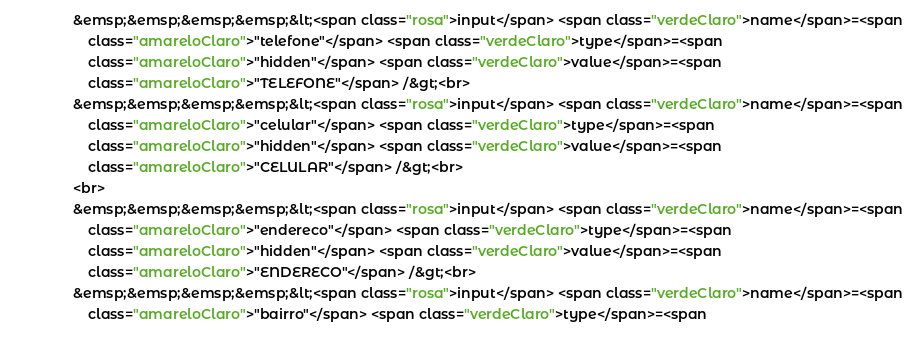<code> <loc_0><loc_0><loc_500><loc_500><_HTML_>                &emsp;&emsp;&emsp;&emsp;&lt;<span class="rosa">input</span> <span class="verdeClaro">name</span>=<span
                    class="amareloClaro">"telefone"</span> <span class="verdeClaro">type</span>=<span
                    class="amareloClaro">"hidden"</span> <span class="verdeClaro">value</span>=<span
                    class="amareloClaro">"TELEFONE"</span> /&gt;<br>
                &emsp;&emsp;&emsp;&emsp;&lt;<span class="rosa">input</span> <span class="verdeClaro">name</span>=<span
                    class="amareloClaro">"celular"</span> <span class="verdeClaro">type</span>=<span
                    class="amareloClaro">"hidden"</span> <span class="verdeClaro">value</span>=<span
                    class="amareloClaro">"CELULAR"</span> /&gt;<br>
                <br>
                &emsp;&emsp;&emsp;&emsp;&lt;<span class="rosa">input</span> <span class="verdeClaro">name</span>=<span
                    class="amareloClaro">"endereco"</span> <span class="verdeClaro">type</span>=<span
                    class="amareloClaro">"hidden"</span> <span class="verdeClaro">value</span>=<span
                    class="amareloClaro">"ENDERECO"</span> /&gt;<br>
                &emsp;&emsp;&emsp;&emsp;&lt;<span class="rosa">input</span> <span class="verdeClaro">name</span>=<span
                    class="amareloClaro">"bairro"</span> <span class="verdeClaro">type</span>=<span</code> 